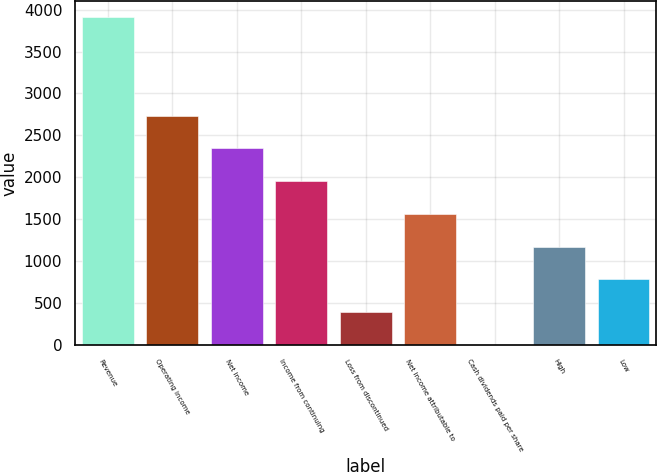Convert chart to OTSL. <chart><loc_0><loc_0><loc_500><loc_500><bar_chart><fcel>Revenue<fcel>Operating income<fcel>Net income<fcel>Income from continuing<fcel>Loss from discontinued<fcel>Net income attributable to<fcel>Cash dividends paid per share<fcel>High<fcel>Low<nl><fcel>3907<fcel>2734.92<fcel>2344.23<fcel>1953.54<fcel>390.78<fcel>1562.85<fcel>0.09<fcel>1172.16<fcel>781.47<nl></chart> 